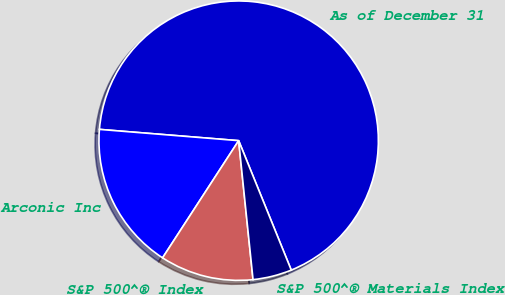Convert chart. <chart><loc_0><loc_0><loc_500><loc_500><pie_chart><fcel>As of December 31<fcel>Arconic Inc<fcel>S&P 500^® Index<fcel>S&P 500^® Materials Index<nl><fcel>67.57%<fcel>17.12%<fcel>10.81%<fcel>4.5%<nl></chart> 